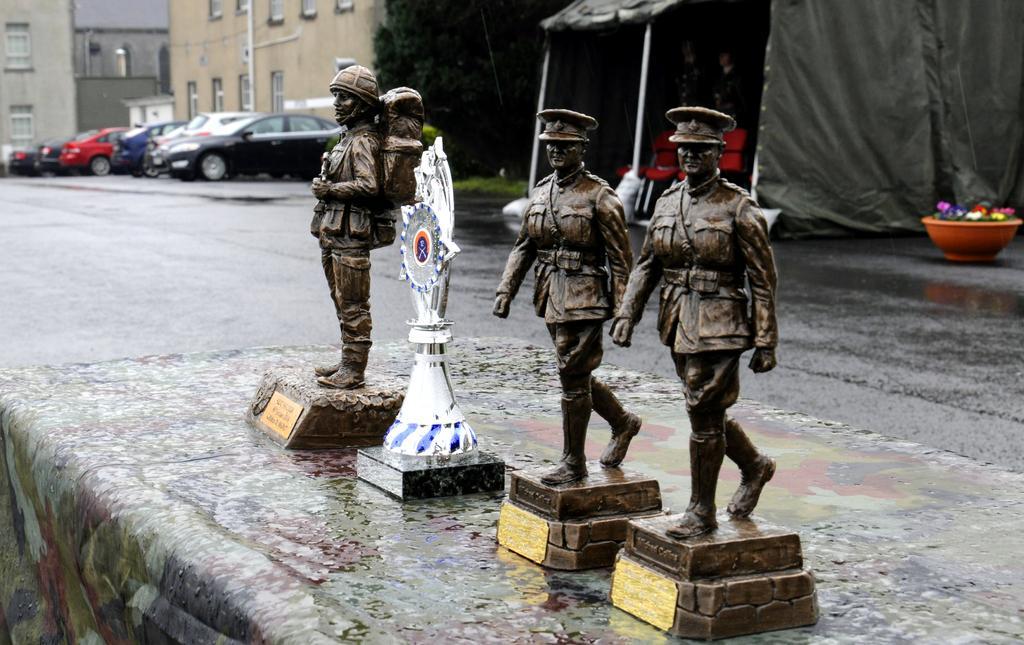Could you give a brief overview of what you see in this image? This image consists of sculptures which are kept on the road. In the middle, there is an award. To the left, there are many cars parked. And there are building above the windows. To the right, there is a tent. At the bottom, there is a road. 